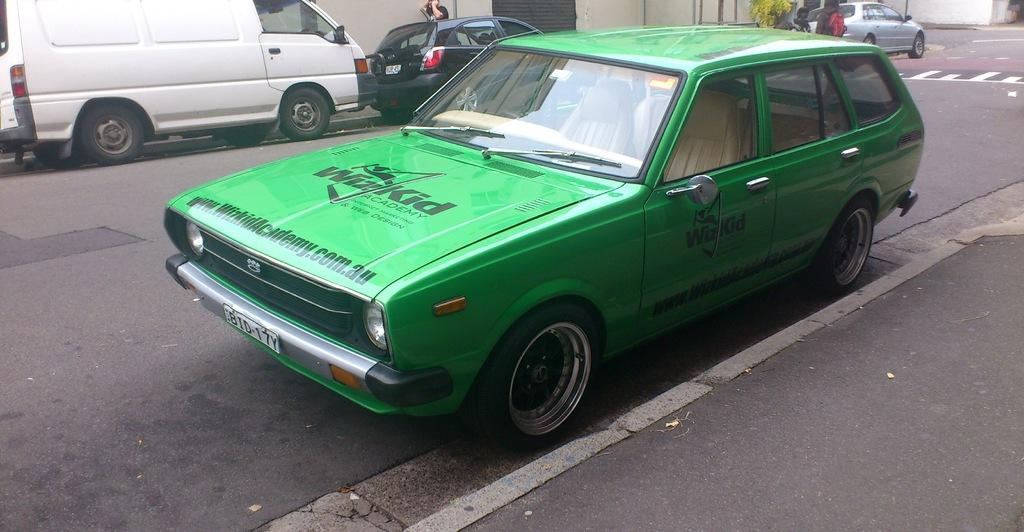What can be seen on the road in the image? There are vehicles on the road in the image. Can you describe the presence of a person in the image? Yes, there is a person in the image. What type of test is being conducted by the person in the image? There is no indication in the image that a test is being conducted, nor is there any reference to a test. Can you see any stamps or postage materials in the image? There is no mention or visual reference to stamps or postage materials in the image. 